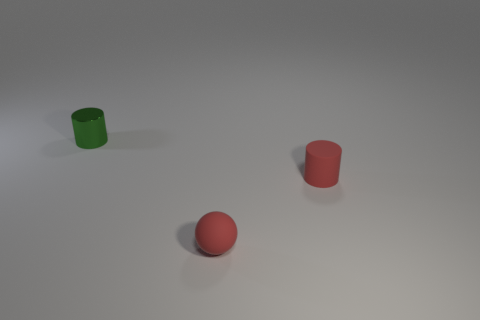What kind of lighting setup is suggested by the shadows and highlights in the image? The shadows cast by the objects are short and faint, indicating a diffuse overhead light source, like a softbox or a cloudy sky. This creates a gentle contrast with soft edges on the shadows, which is common in studio photography to avoid harsh shadows and to evenly light the subjects. 